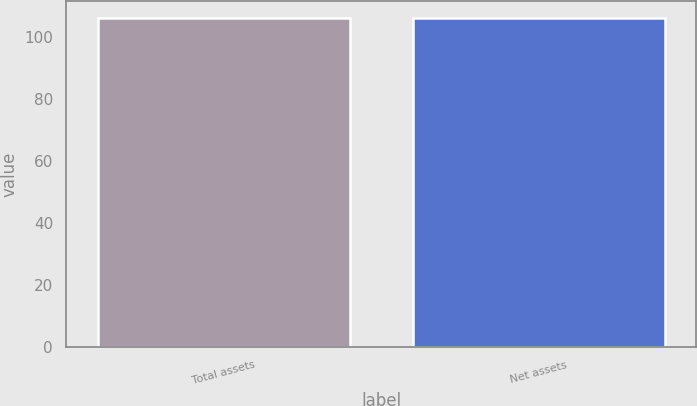Convert chart. <chart><loc_0><loc_0><loc_500><loc_500><bar_chart><fcel>Total assets<fcel>Net assets<nl><fcel>106<fcel>106.1<nl></chart> 